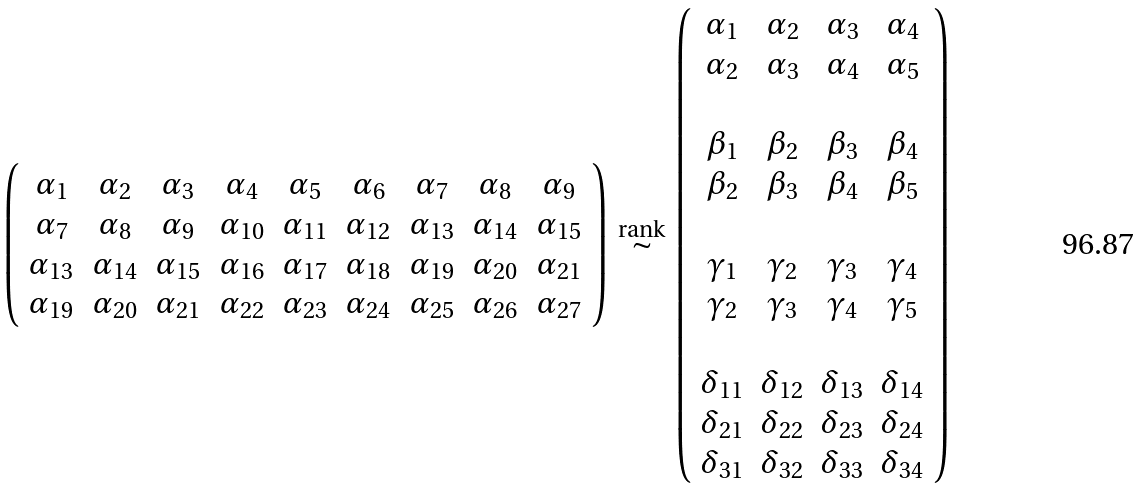<formula> <loc_0><loc_0><loc_500><loc_500>\left ( \begin{array} { c c c c c c c c c } \alpha _ { 1 } & \alpha _ { 2 } & \alpha _ { 3 } & \alpha _ { 4 } & \alpha _ { 5 } & \alpha _ { 6 } & \alpha _ { 7 } & \alpha _ { 8 } & \alpha _ { 9 } \\ \alpha _ { 7 } & \alpha _ { 8 } & \alpha _ { 9 } & \alpha _ { 1 0 } & \alpha _ { 1 1 } & \alpha _ { 1 2 } & \alpha _ { 1 3 } & \alpha _ { 1 4 } & \alpha _ { 1 5 } \\ \alpha _ { 1 3 } & \alpha _ { 1 4 } & \alpha _ { 1 5 } & \alpha _ { 1 6 } & \alpha _ { 1 7 } & \alpha _ { 1 8 } & \alpha _ { 1 9 } & \alpha _ { 2 0 } & \alpha _ { 2 1 } \\ \alpha _ { 1 9 } & \alpha _ { 2 0 } & \alpha _ { 2 1 } & \alpha _ { 2 2 } & \alpha _ { 2 3 } & \alpha _ { 2 4 } & \alpha _ { 2 5 } & \alpha _ { 2 6 } & \alpha _ { 2 7 } \end{array} \right ) \, \overset { \text {rank} } { \sim } \, \left ( \begin{array} { c c c c } \alpha _ { 1 } & \alpha _ { 2 } & \alpha _ { 3 } & \alpha _ { 4 } \\ \alpha _ { 2 } & \alpha _ { 3 } & \alpha _ { 4 } & \alpha _ { 5 } \\ \\ \beta _ { 1 } & \beta _ { 2 } & \beta _ { 3 } & \beta _ { 4 } \\ \beta _ { 2 } & \beta _ { 3 } & \beta _ { 4 } & \beta _ { 5 } \\ \\ \gamma _ { 1 } & \gamma _ { 2 } & \gamma _ { 3 } & \gamma _ { 4 } \\ \gamma _ { 2 } & \gamma _ { 3 } & \gamma _ { 4 } & \gamma _ { 5 } \\ \\ \delta _ { 1 1 } & \delta _ { 1 2 } & \delta _ { 1 3 } & \delta _ { 1 4 } \\ \delta _ { 2 1 } & \delta _ { 2 2 } & \delta _ { 2 3 } & \delta _ { 2 4 } \\ \delta _ { 3 1 } & \delta _ { 3 2 } & \delta _ { 3 3 } & \delta _ { 3 4 } \end{array} \right )</formula> 